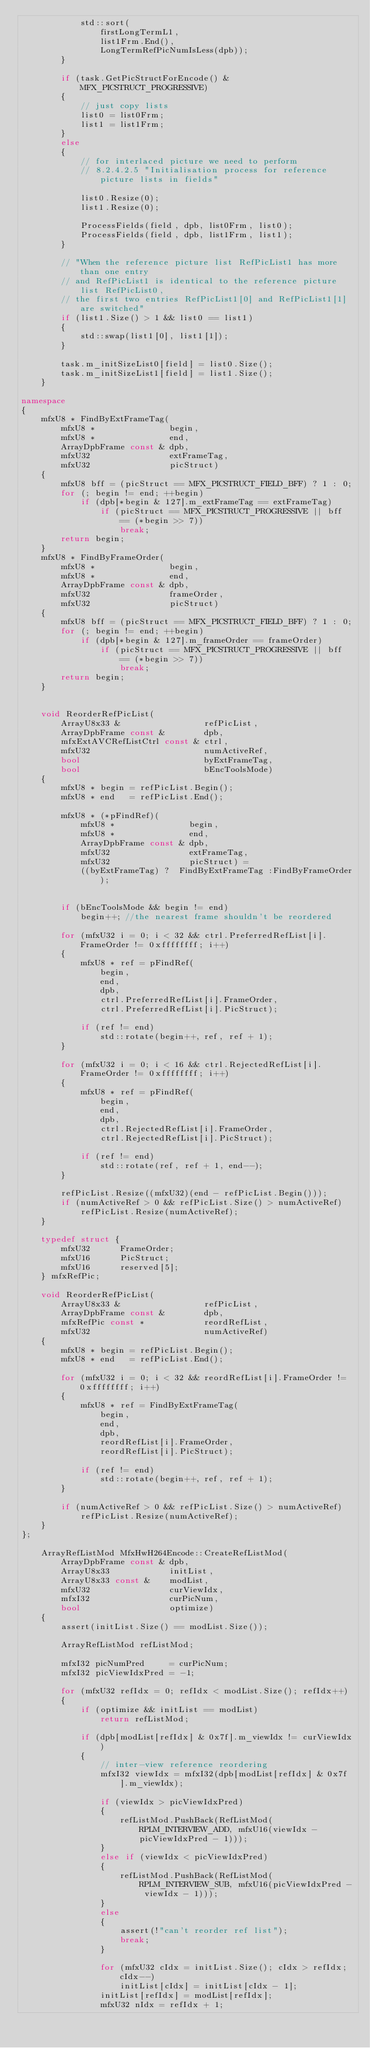<code> <loc_0><loc_0><loc_500><loc_500><_C++_>            std::sort(
                firstLongTermL1,
                list1Frm.End(),
                LongTermRefPicNumIsLess(dpb));
        }

        if (task.GetPicStructForEncode() & MFX_PICSTRUCT_PROGRESSIVE)
        {
            // just copy lists
            list0 = list0Frm;
            list1 = list1Frm;
        }
        else
        {
            // for interlaced picture we need to perform
            // 8.2.4.2.5 "Initialisation process for reference picture lists in fields"

            list0.Resize(0);
            list1.Resize(0);

            ProcessFields(field, dpb, list0Frm, list0);
            ProcessFields(field, dpb, list1Frm, list1);
        }

        // "When the reference picture list RefPicList1 has more than one entry
        // and RefPicList1 is identical to the reference picture list RefPicList0,
        // the first two entries RefPicList1[0] and RefPicList1[1] are switched"
        if (list1.Size() > 1 && list0 == list1)
        {
            std::swap(list1[0], list1[1]);
        }

        task.m_initSizeList0[field] = list0.Size();
        task.m_initSizeList1[field] = list1.Size();
    }

namespace
{
    mfxU8 * FindByExtFrameTag(
        mfxU8 *               begin,
        mfxU8 *               end,
        ArrayDpbFrame const & dpb,
        mfxU32                extFrameTag,
        mfxU32                picStruct)
    {
        mfxU8 bff = (picStruct == MFX_PICSTRUCT_FIELD_BFF) ? 1 : 0;
        for (; begin != end; ++begin)
            if (dpb[*begin & 127].m_extFrameTag == extFrameTag)
                if (picStruct == MFX_PICSTRUCT_PROGRESSIVE || bff == (*begin >> 7))
                    break;
        return begin;
    }
    mfxU8 * FindByFrameOrder(
        mfxU8 *               begin,
        mfxU8 *               end,
        ArrayDpbFrame const & dpb,
        mfxU32                frameOrder,
        mfxU32                picStruct)
    {
        mfxU8 bff = (picStruct == MFX_PICSTRUCT_FIELD_BFF) ? 1 : 0;
        for (; begin != end; ++begin)
            if (dpb[*begin & 127].m_frameOrder == frameOrder)
                if (picStruct == MFX_PICSTRUCT_PROGRESSIVE || bff == (*begin >> 7))
                    break;
        return begin;
    }


    void ReorderRefPicList(
        ArrayU8x33 &                 refPicList,
        ArrayDpbFrame const &        dpb,
        mfxExtAVCRefListCtrl const & ctrl,
        mfxU32                       numActiveRef,
        bool                         byExtFrameTag,
        bool                         bEncToolsMode)
    {
        mfxU8 * begin = refPicList.Begin();
        mfxU8 * end   = refPicList.End();

        mfxU8 * (*pFindRef)(
            mfxU8 *               begin,
            mfxU8 *               end,
            ArrayDpbFrame const & dpb,
            mfxU32                extFrameTag,
            mfxU32                picStruct) =
            ((byExtFrameTag) ?  FindByExtFrameTag :FindByFrameOrder);


        if (bEncToolsMode && begin != end)
            begin++; //the nearest frame shouldn't be reordered

        for (mfxU32 i = 0; i < 32 && ctrl.PreferredRefList[i].FrameOrder != 0xffffffff; i++)
        {
            mfxU8 * ref = pFindRef(
                begin,
                end,
                dpb,
                ctrl.PreferredRefList[i].FrameOrder,
                ctrl.PreferredRefList[i].PicStruct);

            if (ref != end)
                std::rotate(begin++, ref, ref + 1);
        }

        for (mfxU32 i = 0; i < 16 && ctrl.RejectedRefList[i].FrameOrder != 0xffffffff; i++)
        {
            mfxU8 * ref = pFindRef(
                begin,
                end,
                dpb,
                ctrl.RejectedRefList[i].FrameOrder,
                ctrl.RejectedRefList[i].PicStruct);

            if (ref != end)
                std::rotate(ref, ref + 1, end--);
        }

        refPicList.Resize((mfxU32)(end - refPicList.Begin()));
        if (numActiveRef > 0 && refPicList.Size() > numActiveRef)
            refPicList.Resize(numActiveRef);
    }

    typedef struct {
        mfxU32      FrameOrder;
        mfxU16      PicStruct;
        mfxU16      reserved[5];
    } mfxRefPic;

    void ReorderRefPicList(
        ArrayU8x33 &                 refPicList,
        ArrayDpbFrame const &        dpb,
        mfxRefPic const *            reordRefList,
        mfxU32                       numActiveRef)
    {
        mfxU8 * begin = refPicList.Begin();
        mfxU8 * end   = refPicList.End();

        for (mfxU32 i = 0; i < 32 && reordRefList[i].FrameOrder != 0xffffffff; i++)
        {
            mfxU8 * ref = FindByExtFrameTag(
                begin,
                end,
                dpb,
                reordRefList[i].FrameOrder,
                reordRefList[i].PicStruct);

            if (ref != end)
                std::rotate(begin++, ref, ref + 1);
        }

        if (numActiveRef > 0 && refPicList.Size() > numActiveRef)
            refPicList.Resize(numActiveRef);
    }
};

    ArrayRefListMod MfxHwH264Encode::CreateRefListMod(
        ArrayDpbFrame const & dpb,
        ArrayU8x33            initList,
        ArrayU8x33 const &    modList,
        mfxU32                curViewIdx,
        mfxI32                curPicNum,
        bool                  optimize)
    {
        assert(initList.Size() == modList.Size());

        ArrayRefListMod refListMod;

        mfxI32 picNumPred     = curPicNum;
        mfxI32 picViewIdxPred = -1;

        for (mfxU32 refIdx = 0; refIdx < modList.Size(); refIdx++)
        {
            if (optimize && initList == modList)
                return refListMod;

            if (dpb[modList[refIdx] & 0x7f].m_viewIdx != curViewIdx)
            {
                // inter-view reference reordering
                mfxI32 viewIdx = mfxI32(dpb[modList[refIdx] & 0x7f].m_viewIdx);

                if (viewIdx > picViewIdxPred)
                {
                    refListMod.PushBack(RefListMod(RPLM_INTERVIEW_ADD, mfxU16(viewIdx - picViewIdxPred - 1)));
                }
                else if (viewIdx < picViewIdxPred)
                {
                    refListMod.PushBack(RefListMod(RPLM_INTERVIEW_SUB, mfxU16(picViewIdxPred - viewIdx - 1)));
                }
                else
                {
                    assert(!"can't reorder ref list");
                    break;
                }

                for (mfxU32 cIdx = initList.Size(); cIdx > refIdx; cIdx--)
                    initList[cIdx] = initList[cIdx - 1];
                initList[refIdx] = modList[refIdx];
                mfxU32 nIdx = refIdx + 1;</code> 